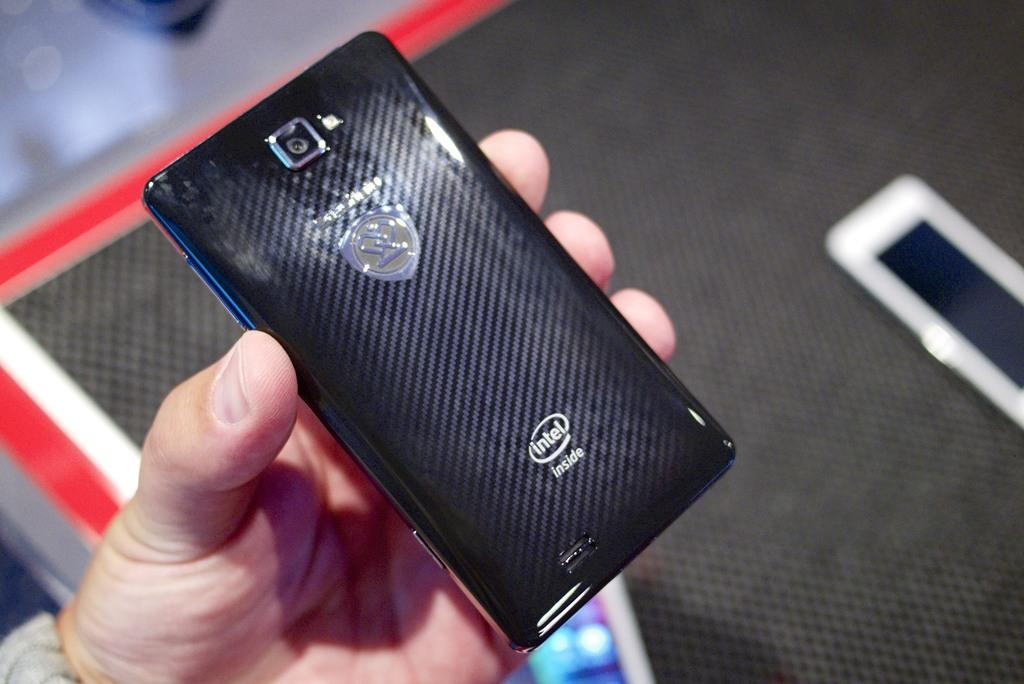What is the main subject of the image? There is a person in the image. What is the person holding in the image? The person is holding a mobile phone. What part of the person's body is visible in the image? Human hands are visible in the image. What type of operation is the person performing on the wrist in the image? There is no wrist or operation present in the image; the person is simply holding a mobile phone. 